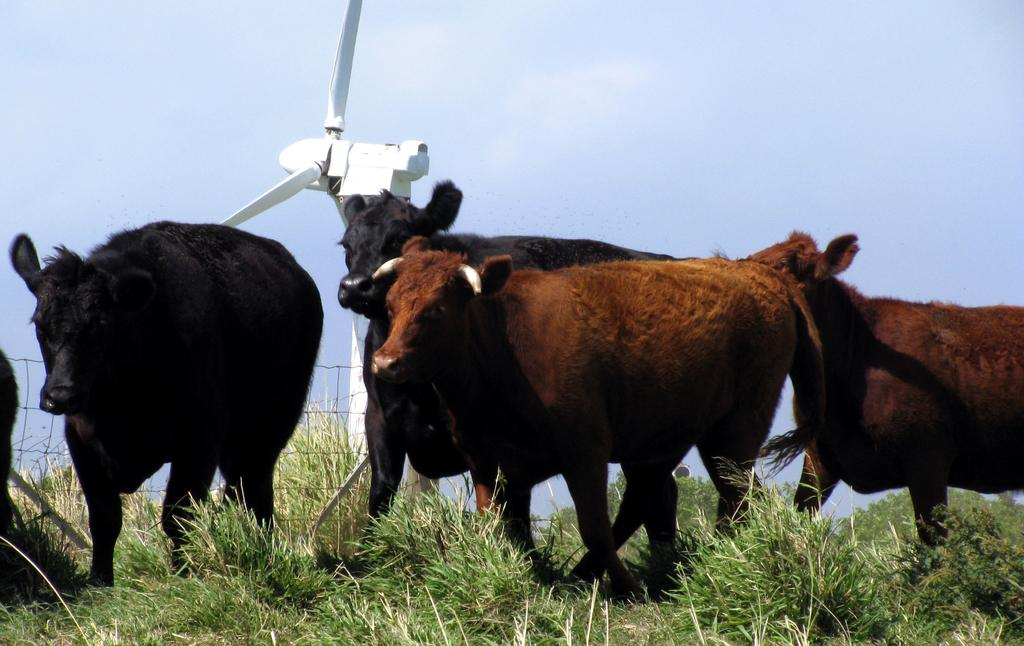What is on the ground in the image? There are animals standing on the ground in the image. What type of vegetation covers the ground? The ground is covered with grass. What can be seen in the background of the image? There is a windmill in the background of the image. What is the condition of the sky in the image? The sky is clear and visible in the image. What type of guitar is being played by the animals in the image? There is no guitar present in the image; the animals are standing on the ground with grass beneath them. What medical advice are the animals seeking from the doctor in the image? There is no doctor present in the image; the focus is on the animals standing on the ground and the windmill in the background. 